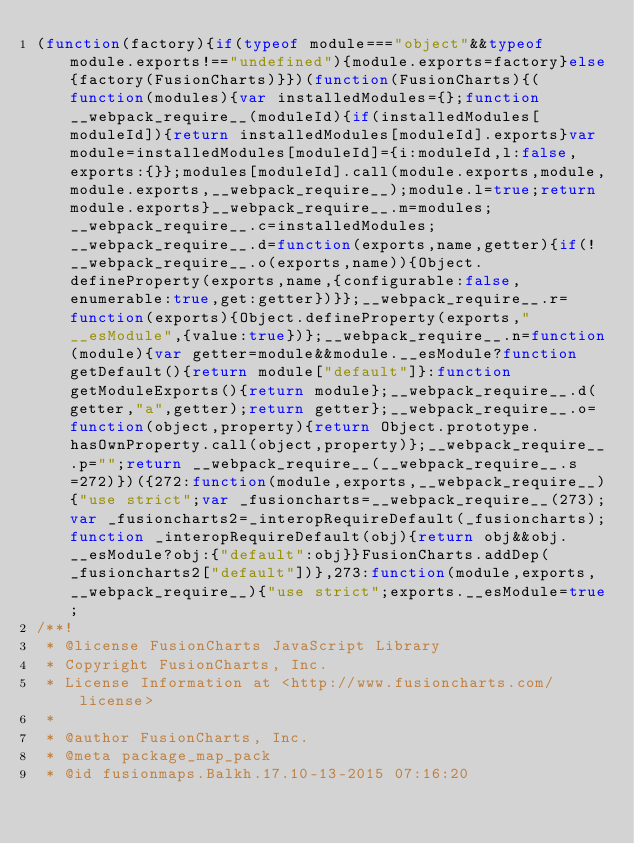Convert code to text. <code><loc_0><loc_0><loc_500><loc_500><_JavaScript_>(function(factory){if(typeof module==="object"&&typeof module.exports!=="undefined"){module.exports=factory}else{factory(FusionCharts)}})(function(FusionCharts){(function(modules){var installedModules={};function __webpack_require__(moduleId){if(installedModules[moduleId]){return installedModules[moduleId].exports}var module=installedModules[moduleId]={i:moduleId,l:false,exports:{}};modules[moduleId].call(module.exports,module,module.exports,__webpack_require__);module.l=true;return module.exports}__webpack_require__.m=modules;__webpack_require__.c=installedModules;__webpack_require__.d=function(exports,name,getter){if(!__webpack_require__.o(exports,name)){Object.defineProperty(exports,name,{configurable:false,enumerable:true,get:getter})}};__webpack_require__.r=function(exports){Object.defineProperty(exports,"__esModule",{value:true})};__webpack_require__.n=function(module){var getter=module&&module.__esModule?function getDefault(){return module["default"]}:function getModuleExports(){return module};__webpack_require__.d(getter,"a",getter);return getter};__webpack_require__.o=function(object,property){return Object.prototype.hasOwnProperty.call(object,property)};__webpack_require__.p="";return __webpack_require__(__webpack_require__.s=272)})({272:function(module,exports,__webpack_require__){"use strict";var _fusioncharts=__webpack_require__(273);var _fusioncharts2=_interopRequireDefault(_fusioncharts);function _interopRequireDefault(obj){return obj&&obj.__esModule?obj:{"default":obj}}FusionCharts.addDep(_fusioncharts2["default"])},273:function(module,exports,__webpack_require__){"use strict";exports.__esModule=true;
/**!
 * @license FusionCharts JavaScript Library
 * Copyright FusionCharts, Inc.
 * License Information at <http://www.fusioncharts.com/license>
 *
 * @author FusionCharts, Inc.
 * @meta package_map_pack
 * @id fusionmaps.Balkh.17.10-13-2015 07:16:20</code> 